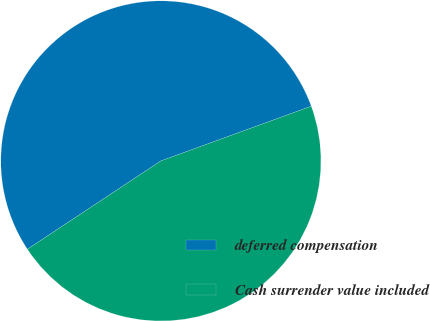Convert chart. <chart><loc_0><loc_0><loc_500><loc_500><pie_chart><fcel>deferred compensation<fcel>Cash surrender value included<nl><fcel>53.75%<fcel>46.25%<nl></chart> 